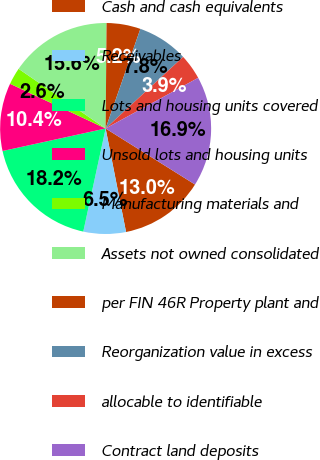Convert chart to OTSL. <chart><loc_0><loc_0><loc_500><loc_500><pie_chart><fcel>Cash and cash equivalents<fcel>Receivables<fcel>Lots and housing units covered<fcel>Unsold lots and housing units<fcel>Manufacturing materials and<fcel>Assets not owned consolidated<fcel>per FIN 46R Property plant and<fcel>Reorganization value in excess<fcel>allocable to identifiable<fcel>Contract land deposits<nl><fcel>12.99%<fcel>6.5%<fcel>18.18%<fcel>10.39%<fcel>2.6%<fcel>15.58%<fcel>5.2%<fcel>7.79%<fcel>3.9%<fcel>16.88%<nl></chart> 